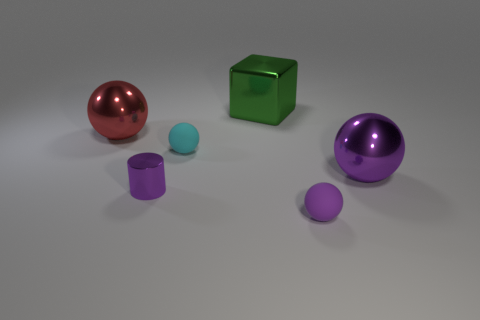What shape is most abundant in this image? Spheres are the most abundant shape in this image, with three of them present in different sizes and colors. 